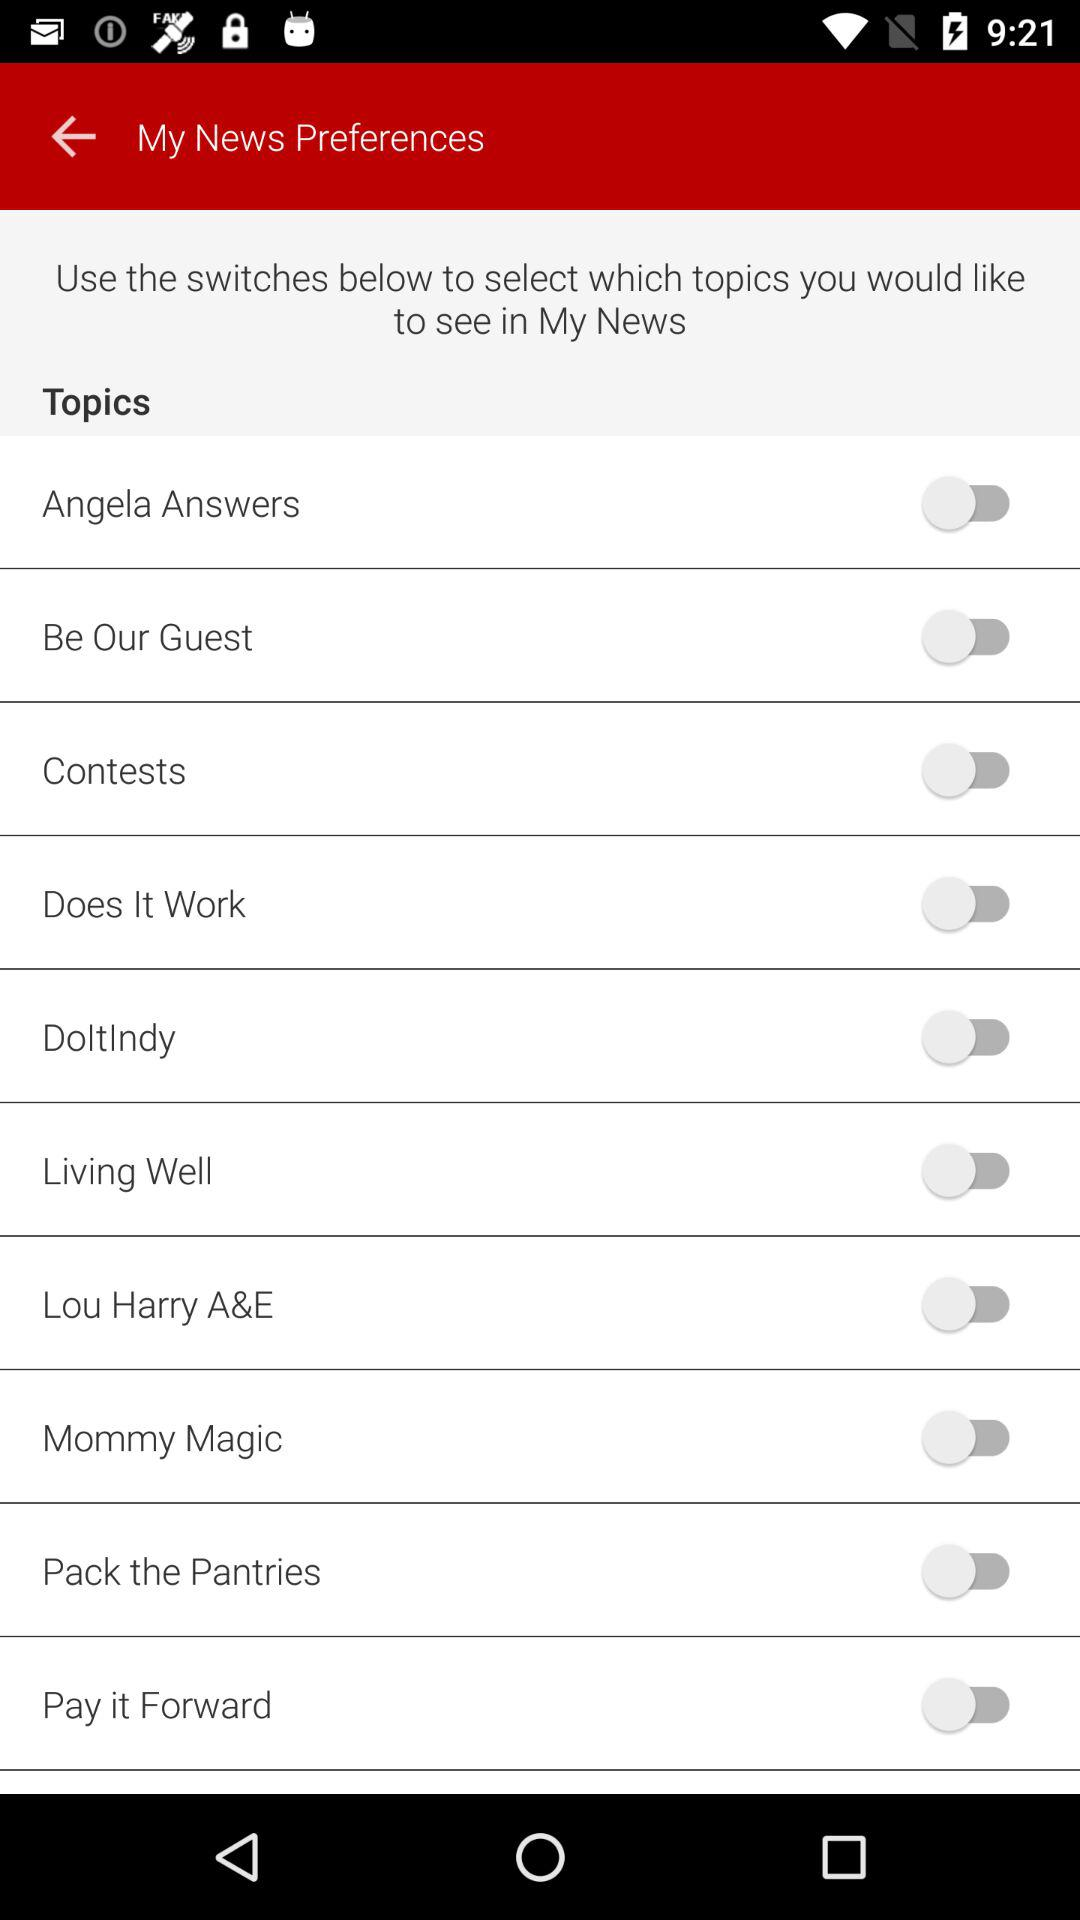What is the status of the contests topic? The status is off. 